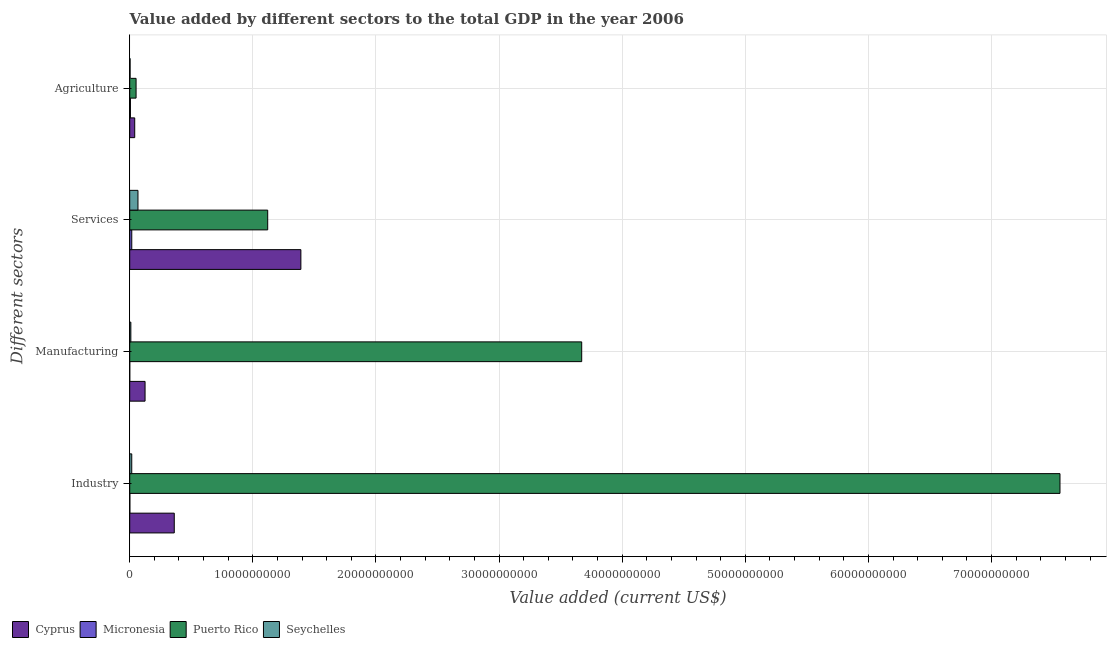How many bars are there on the 3rd tick from the top?
Offer a terse response. 4. What is the label of the 4th group of bars from the top?
Keep it short and to the point. Industry. What is the value added by agricultural sector in Cyprus?
Offer a terse response. 4.05e+08. Across all countries, what is the maximum value added by manufacturing sector?
Give a very brief answer. 3.67e+1. In which country was the value added by services sector maximum?
Provide a short and direct response. Cyprus. In which country was the value added by manufacturing sector minimum?
Keep it short and to the point. Micronesia. What is the total value added by agricultural sector in the graph?
Ensure brevity in your answer.  1.01e+09. What is the difference between the value added by agricultural sector in Puerto Rico and that in Cyprus?
Provide a succinct answer. 1.11e+08. What is the difference between the value added by industrial sector in Seychelles and the value added by manufacturing sector in Cyprus?
Your answer should be very brief. -1.08e+09. What is the average value added by industrial sector per country?
Your answer should be very brief. 1.98e+1. What is the difference between the value added by services sector and value added by manufacturing sector in Micronesia?
Your answer should be very brief. 1.64e+08. What is the ratio of the value added by services sector in Micronesia to that in Cyprus?
Make the answer very short. 0.01. What is the difference between the highest and the second highest value added by industrial sector?
Keep it short and to the point. 7.19e+1. What is the difference between the highest and the lowest value added by agricultural sector?
Keep it short and to the point. 4.85e+08. In how many countries, is the value added by manufacturing sector greater than the average value added by manufacturing sector taken over all countries?
Your answer should be very brief. 1. Is it the case that in every country, the sum of the value added by industrial sector and value added by agricultural sector is greater than the sum of value added by manufacturing sector and value added by services sector?
Your answer should be compact. No. What does the 3rd bar from the top in Manufacturing represents?
Offer a very short reply. Micronesia. What does the 4th bar from the bottom in Manufacturing represents?
Give a very brief answer. Seychelles. Are all the bars in the graph horizontal?
Your answer should be compact. Yes. How many countries are there in the graph?
Give a very brief answer. 4. Are the values on the major ticks of X-axis written in scientific E-notation?
Provide a succinct answer. No. Does the graph contain any zero values?
Offer a very short reply. No. Does the graph contain grids?
Make the answer very short. Yes. Where does the legend appear in the graph?
Your answer should be compact. Bottom left. What is the title of the graph?
Offer a very short reply. Value added by different sectors to the total GDP in the year 2006. What is the label or title of the X-axis?
Make the answer very short. Value added (current US$). What is the label or title of the Y-axis?
Provide a succinct answer. Different sectors. What is the Value added (current US$) in Cyprus in Industry?
Provide a short and direct response. 3.62e+09. What is the Value added (current US$) in Micronesia in Industry?
Your answer should be compact. 1.02e+07. What is the Value added (current US$) of Puerto Rico in Industry?
Offer a very short reply. 7.56e+1. What is the Value added (current US$) of Seychelles in Industry?
Provide a succinct answer. 1.65e+08. What is the Value added (current US$) in Cyprus in Manufacturing?
Keep it short and to the point. 1.25e+09. What is the Value added (current US$) in Puerto Rico in Manufacturing?
Give a very brief answer. 3.67e+1. What is the Value added (current US$) in Seychelles in Manufacturing?
Make the answer very short. 9.11e+07. What is the Value added (current US$) in Cyprus in Services?
Offer a terse response. 1.39e+1. What is the Value added (current US$) of Micronesia in Services?
Offer a very short reply. 1.65e+08. What is the Value added (current US$) of Puerto Rico in Services?
Your answer should be very brief. 1.12e+1. What is the Value added (current US$) in Seychelles in Services?
Your answer should be compact. 6.70e+08. What is the Value added (current US$) of Cyprus in Agriculture?
Provide a succinct answer. 4.05e+08. What is the Value added (current US$) in Micronesia in Agriculture?
Provide a short and direct response. 5.67e+07. What is the Value added (current US$) in Puerto Rico in Agriculture?
Ensure brevity in your answer.  5.16e+08. What is the Value added (current US$) in Seychelles in Agriculture?
Your answer should be compact. 3.03e+07. Across all Different sectors, what is the maximum Value added (current US$) of Cyprus?
Provide a succinct answer. 1.39e+1. Across all Different sectors, what is the maximum Value added (current US$) in Micronesia?
Your response must be concise. 1.65e+08. Across all Different sectors, what is the maximum Value added (current US$) of Puerto Rico?
Your response must be concise. 7.56e+1. Across all Different sectors, what is the maximum Value added (current US$) of Seychelles?
Offer a very short reply. 6.70e+08. Across all Different sectors, what is the minimum Value added (current US$) in Cyprus?
Provide a succinct answer. 4.05e+08. Across all Different sectors, what is the minimum Value added (current US$) of Puerto Rico?
Ensure brevity in your answer.  5.16e+08. Across all Different sectors, what is the minimum Value added (current US$) of Seychelles?
Make the answer very short. 3.03e+07. What is the total Value added (current US$) in Cyprus in the graph?
Provide a succinct answer. 1.92e+1. What is the total Value added (current US$) in Micronesia in the graph?
Your response must be concise. 2.33e+08. What is the total Value added (current US$) in Puerto Rico in the graph?
Ensure brevity in your answer.  1.24e+11. What is the total Value added (current US$) in Seychelles in the graph?
Offer a terse response. 9.56e+08. What is the difference between the Value added (current US$) in Cyprus in Industry and that in Manufacturing?
Keep it short and to the point. 2.37e+09. What is the difference between the Value added (current US$) of Micronesia in Industry and that in Manufacturing?
Keep it short and to the point. 9.20e+06. What is the difference between the Value added (current US$) of Puerto Rico in Industry and that in Manufacturing?
Keep it short and to the point. 3.88e+1. What is the difference between the Value added (current US$) of Seychelles in Industry and that in Manufacturing?
Provide a succinct answer. 7.39e+07. What is the difference between the Value added (current US$) of Cyprus in Industry and that in Services?
Make the answer very short. -1.03e+1. What is the difference between the Value added (current US$) of Micronesia in Industry and that in Services?
Your answer should be compact. -1.55e+08. What is the difference between the Value added (current US$) in Puerto Rico in Industry and that in Services?
Your answer should be very brief. 6.43e+1. What is the difference between the Value added (current US$) in Seychelles in Industry and that in Services?
Offer a very short reply. -5.05e+08. What is the difference between the Value added (current US$) in Cyprus in Industry and that in Agriculture?
Ensure brevity in your answer.  3.21e+09. What is the difference between the Value added (current US$) in Micronesia in Industry and that in Agriculture?
Provide a short and direct response. -4.65e+07. What is the difference between the Value added (current US$) of Puerto Rico in Industry and that in Agriculture?
Your answer should be compact. 7.50e+1. What is the difference between the Value added (current US$) of Seychelles in Industry and that in Agriculture?
Your response must be concise. 1.35e+08. What is the difference between the Value added (current US$) in Cyprus in Manufacturing and that in Services?
Give a very brief answer. -1.27e+1. What is the difference between the Value added (current US$) in Micronesia in Manufacturing and that in Services?
Your response must be concise. -1.64e+08. What is the difference between the Value added (current US$) in Puerto Rico in Manufacturing and that in Services?
Make the answer very short. 2.55e+1. What is the difference between the Value added (current US$) of Seychelles in Manufacturing and that in Services?
Give a very brief answer. -5.79e+08. What is the difference between the Value added (current US$) in Cyprus in Manufacturing and that in Agriculture?
Give a very brief answer. 8.40e+08. What is the difference between the Value added (current US$) of Micronesia in Manufacturing and that in Agriculture?
Offer a very short reply. -5.57e+07. What is the difference between the Value added (current US$) in Puerto Rico in Manufacturing and that in Agriculture?
Keep it short and to the point. 3.62e+1. What is the difference between the Value added (current US$) of Seychelles in Manufacturing and that in Agriculture?
Provide a short and direct response. 6.08e+07. What is the difference between the Value added (current US$) of Cyprus in Services and that in Agriculture?
Offer a terse response. 1.35e+1. What is the difference between the Value added (current US$) in Micronesia in Services and that in Agriculture?
Keep it short and to the point. 1.08e+08. What is the difference between the Value added (current US$) of Puerto Rico in Services and that in Agriculture?
Keep it short and to the point. 1.07e+1. What is the difference between the Value added (current US$) in Seychelles in Services and that in Agriculture?
Ensure brevity in your answer.  6.39e+08. What is the difference between the Value added (current US$) of Cyprus in Industry and the Value added (current US$) of Micronesia in Manufacturing?
Provide a succinct answer. 3.62e+09. What is the difference between the Value added (current US$) in Cyprus in Industry and the Value added (current US$) in Puerto Rico in Manufacturing?
Your answer should be very brief. -3.31e+1. What is the difference between the Value added (current US$) of Cyprus in Industry and the Value added (current US$) of Seychelles in Manufacturing?
Keep it short and to the point. 3.53e+09. What is the difference between the Value added (current US$) in Micronesia in Industry and the Value added (current US$) in Puerto Rico in Manufacturing?
Your answer should be very brief. -3.67e+1. What is the difference between the Value added (current US$) in Micronesia in Industry and the Value added (current US$) in Seychelles in Manufacturing?
Offer a terse response. -8.09e+07. What is the difference between the Value added (current US$) in Puerto Rico in Industry and the Value added (current US$) in Seychelles in Manufacturing?
Provide a short and direct response. 7.55e+1. What is the difference between the Value added (current US$) in Cyprus in Industry and the Value added (current US$) in Micronesia in Services?
Your response must be concise. 3.45e+09. What is the difference between the Value added (current US$) of Cyprus in Industry and the Value added (current US$) of Puerto Rico in Services?
Provide a short and direct response. -7.59e+09. What is the difference between the Value added (current US$) in Cyprus in Industry and the Value added (current US$) in Seychelles in Services?
Your answer should be very brief. 2.95e+09. What is the difference between the Value added (current US$) in Micronesia in Industry and the Value added (current US$) in Puerto Rico in Services?
Give a very brief answer. -1.12e+1. What is the difference between the Value added (current US$) of Micronesia in Industry and the Value added (current US$) of Seychelles in Services?
Your answer should be compact. -6.60e+08. What is the difference between the Value added (current US$) in Puerto Rico in Industry and the Value added (current US$) in Seychelles in Services?
Keep it short and to the point. 7.49e+1. What is the difference between the Value added (current US$) in Cyprus in Industry and the Value added (current US$) in Micronesia in Agriculture?
Make the answer very short. 3.56e+09. What is the difference between the Value added (current US$) of Cyprus in Industry and the Value added (current US$) of Puerto Rico in Agriculture?
Give a very brief answer. 3.10e+09. What is the difference between the Value added (current US$) of Cyprus in Industry and the Value added (current US$) of Seychelles in Agriculture?
Keep it short and to the point. 3.59e+09. What is the difference between the Value added (current US$) of Micronesia in Industry and the Value added (current US$) of Puerto Rico in Agriculture?
Ensure brevity in your answer.  -5.05e+08. What is the difference between the Value added (current US$) in Micronesia in Industry and the Value added (current US$) in Seychelles in Agriculture?
Your answer should be very brief. -2.01e+07. What is the difference between the Value added (current US$) of Puerto Rico in Industry and the Value added (current US$) of Seychelles in Agriculture?
Keep it short and to the point. 7.55e+1. What is the difference between the Value added (current US$) in Cyprus in Manufacturing and the Value added (current US$) in Micronesia in Services?
Provide a succinct answer. 1.08e+09. What is the difference between the Value added (current US$) of Cyprus in Manufacturing and the Value added (current US$) of Puerto Rico in Services?
Keep it short and to the point. -9.96e+09. What is the difference between the Value added (current US$) in Cyprus in Manufacturing and the Value added (current US$) in Seychelles in Services?
Provide a short and direct response. 5.76e+08. What is the difference between the Value added (current US$) of Micronesia in Manufacturing and the Value added (current US$) of Puerto Rico in Services?
Your response must be concise. -1.12e+1. What is the difference between the Value added (current US$) of Micronesia in Manufacturing and the Value added (current US$) of Seychelles in Services?
Provide a short and direct response. -6.69e+08. What is the difference between the Value added (current US$) in Puerto Rico in Manufacturing and the Value added (current US$) in Seychelles in Services?
Give a very brief answer. 3.60e+1. What is the difference between the Value added (current US$) in Cyprus in Manufacturing and the Value added (current US$) in Micronesia in Agriculture?
Ensure brevity in your answer.  1.19e+09. What is the difference between the Value added (current US$) in Cyprus in Manufacturing and the Value added (current US$) in Puerto Rico in Agriculture?
Ensure brevity in your answer.  7.30e+08. What is the difference between the Value added (current US$) in Cyprus in Manufacturing and the Value added (current US$) in Seychelles in Agriculture?
Your answer should be compact. 1.22e+09. What is the difference between the Value added (current US$) in Micronesia in Manufacturing and the Value added (current US$) in Puerto Rico in Agriculture?
Provide a succinct answer. -5.15e+08. What is the difference between the Value added (current US$) of Micronesia in Manufacturing and the Value added (current US$) of Seychelles in Agriculture?
Offer a terse response. -2.93e+07. What is the difference between the Value added (current US$) in Puerto Rico in Manufacturing and the Value added (current US$) in Seychelles in Agriculture?
Your response must be concise. 3.67e+1. What is the difference between the Value added (current US$) in Cyprus in Services and the Value added (current US$) in Micronesia in Agriculture?
Offer a terse response. 1.38e+1. What is the difference between the Value added (current US$) in Cyprus in Services and the Value added (current US$) in Puerto Rico in Agriculture?
Provide a succinct answer. 1.34e+1. What is the difference between the Value added (current US$) in Cyprus in Services and the Value added (current US$) in Seychelles in Agriculture?
Give a very brief answer. 1.39e+1. What is the difference between the Value added (current US$) of Micronesia in Services and the Value added (current US$) of Puerto Rico in Agriculture?
Give a very brief answer. -3.50e+08. What is the difference between the Value added (current US$) in Micronesia in Services and the Value added (current US$) in Seychelles in Agriculture?
Make the answer very short. 1.35e+08. What is the difference between the Value added (current US$) in Puerto Rico in Services and the Value added (current US$) in Seychelles in Agriculture?
Give a very brief answer. 1.12e+1. What is the average Value added (current US$) of Cyprus per Different sectors?
Offer a very short reply. 4.79e+09. What is the average Value added (current US$) in Micronesia per Different sectors?
Ensure brevity in your answer.  5.83e+07. What is the average Value added (current US$) of Puerto Rico per Different sectors?
Your answer should be compact. 3.10e+1. What is the average Value added (current US$) of Seychelles per Different sectors?
Your response must be concise. 2.39e+08. What is the difference between the Value added (current US$) of Cyprus and Value added (current US$) of Micronesia in Industry?
Keep it short and to the point. 3.61e+09. What is the difference between the Value added (current US$) of Cyprus and Value added (current US$) of Puerto Rico in Industry?
Make the answer very short. -7.19e+1. What is the difference between the Value added (current US$) of Cyprus and Value added (current US$) of Seychelles in Industry?
Ensure brevity in your answer.  3.45e+09. What is the difference between the Value added (current US$) of Micronesia and Value added (current US$) of Puerto Rico in Industry?
Give a very brief answer. -7.55e+1. What is the difference between the Value added (current US$) of Micronesia and Value added (current US$) of Seychelles in Industry?
Ensure brevity in your answer.  -1.55e+08. What is the difference between the Value added (current US$) of Puerto Rico and Value added (current US$) of Seychelles in Industry?
Your answer should be compact. 7.54e+1. What is the difference between the Value added (current US$) in Cyprus and Value added (current US$) in Micronesia in Manufacturing?
Make the answer very short. 1.24e+09. What is the difference between the Value added (current US$) of Cyprus and Value added (current US$) of Puerto Rico in Manufacturing?
Your answer should be very brief. -3.55e+1. What is the difference between the Value added (current US$) of Cyprus and Value added (current US$) of Seychelles in Manufacturing?
Provide a succinct answer. 1.15e+09. What is the difference between the Value added (current US$) of Micronesia and Value added (current US$) of Puerto Rico in Manufacturing?
Keep it short and to the point. -3.67e+1. What is the difference between the Value added (current US$) in Micronesia and Value added (current US$) in Seychelles in Manufacturing?
Provide a short and direct response. -9.01e+07. What is the difference between the Value added (current US$) in Puerto Rico and Value added (current US$) in Seychelles in Manufacturing?
Offer a terse response. 3.66e+1. What is the difference between the Value added (current US$) of Cyprus and Value added (current US$) of Micronesia in Services?
Your answer should be very brief. 1.37e+1. What is the difference between the Value added (current US$) of Cyprus and Value added (current US$) of Puerto Rico in Services?
Ensure brevity in your answer.  2.69e+09. What is the difference between the Value added (current US$) of Cyprus and Value added (current US$) of Seychelles in Services?
Provide a short and direct response. 1.32e+1. What is the difference between the Value added (current US$) in Micronesia and Value added (current US$) in Puerto Rico in Services?
Provide a succinct answer. -1.10e+1. What is the difference between the Value added (current US$) in Micronesia and Value added (current US$) in Seychelles in Services?
Your answer should be compact. -5.05e+08. What is the difference between the Value added (current US$) of Puerto Rico and Value added (current US$) of Seychelles in Services?
Your answer should be compact. 1.05e+1. What is the difference between the Value added (current US$) in Cyprus and Value added (current US$) in Micronesia in Agriculture?
Keep it short and to the point. 3.48e+08. What is the difference between the Value added (current US$) in Cyprus and Value added (current US$) in Puerto Rico in Agriculture?
Your response must be concise. -1.11e+08. What is the difference between the Value added (current US$) of Cyprus and Value added (current US$) of Seychelles in Agriculture?
Keep it short and to the point. 3.75e+08. What is the difference between the Value added (current US$) of Micronesia and Value added (current US$) of Puerto Rico in Agriculture?
Offer a very short reply. -4.59e+08. What is the difference between the Value added (current US$) of Micronesia and Value added (current US$) of Seychelles in Agriculture?
Provide a succinct answer. 2.64e+07. What is the difference between the Value added (current US$) of Puerto Rico and Value added (current US$) of Seychelles in Agriculture?
Keep it short and to the point. 4.85e+08. What is the ratio of the Value added (current US$) of Cyprus in Industry to that in Manufacturing?
Give a very brief answer. 2.9. What is the ratio of the Value added (current US$) in Puerto Rico in Industry to that in Manufacturing?
Offer a very short reply. 2.06. What is the ratio of the Value added (current US$) of Seychelles in Industry to that in Manufacturing?
Keep it short and to the point. 1.81. What is the ratio of the Value added (current US$) of Cyprus in Industry to that in Services?
Ensure brevity in your answer.  0.26. What is the ratio of the Value added (current US$) in Micronesia in Industry to that in Services?
Ensure brevity in your answer.  0.06. What is the ratio of the Value added (current US$) of Puerto Rico in Industry to that in Services?
Provide a short and direct response. 6.74. What is the ratio of the Value added (current US$) in Seychelles in Industry to that in Services?
Ensure brevity in your answer.  0.25. What is the ratio of the Value added (current US$) in Cyprus in Industry to that in Agriculture?
Ensure brevity in your answer.  8.93. What is the ratio of the Value added (current US$) in Micronesia in Industry to that in Agriculture?
Ensure brevity in your answer.  0.18. What is the ratio of the Value added (current US$) of Puerto Rico in Industry to that in Agriculture?
Keep it short and to the point. 146.54. What is the ratio of the Value added (current US$) in Seychelles in Industry to that in Agriculture?
Offer a terse response. 5.45. What is the ratio of the Value added (current US$) in Cyprus in Manufacturing to that in Services?
Your answer should be compact. 0.09. What is the ratio of the Value added (current US$) in Micronesia in Manufacturing to that in Services?
Provide a succinct answer. 0.01. What is the ratio of the Value added (current US$) in Puerto Rico in Manufacturing to that in Services?
Your answer should be compact. 3.28. What is the ratio of the Value added (current US$) of Seychelles in Manufacturing to that in Services?
Offer a terse response. 0.14. What is the ratio of the Value added (current US$) of Cyprus in Manufacturing to that in Agriculture?
Your response must be concise. 3.07. What is the ratio of the Value added (current US$) in Micronesia in Manufacturing to that in Agriculture?
Your answer should be very brief. 0.02. What is the ratio of the Value added (current US$) in Puerto Rico in Manufacturing to that in Agriculture?
Give a very brief answer. 71.2. What is the ratio of the Value added (current US$) in Seychelles in Manufacturing to that in Agriculture?
Keep it short and to the point. 3.01. What is the ratio of the Value added (current US$) in Cyprus in Services to that in Agriculture?
Keep it short and to the point. 34.31. What is the ratio of the Value added (current US$) of Micronesia in Services to that in Agriculture?
Give a very brief answer. 2.91. What is the ratio of the Value added (current US$) in Puerto Rico in Services to that in Agriculture?
Give a very brief answer. 21.73. What is the ratio of the Value added (current US$) of Seychelles in Services to that in Agriculture?
Your answer should be compact. 22.11. What is the difference between the highest and the second highest Value added (current US$) in Cyprus?
Your answer should be very brief. 1.03e+1. What is the difference between the highest and the second highest Value added (current US$) of Micronesia?
Give a very brief answer. 1.08e+08. What is the difference between the highest and the second highest Value added (current US$) in Puerto Rico?
Offer a very short reply. 3.88e+1. What is the difference between the highest and the second highest Value added (current US$) in Seychelles?
Your response must be concise. 5.05e+08. What is the difference between the highest and the lowest Value added (current US$) in Cyprus?
Your answer should be compact. 1.35e+1. What is the difference between the highest and the lowest Value added (current US$) of Micronesia?
Offer a terse response. 1.64e+08. What is the difference between the highest and the lowest Value added (current US$) of Puerto Rico?
Offer a terse response. 7.50e+1. What is the difference between the highest and the lowest Value added (current US$) of Seychelles?
Make the answer very short. 6.39e+08. 